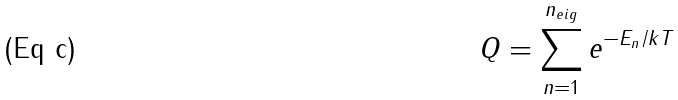<formula> <loc_0><loc_0><loc_500><loc_500>Q = \sum _ { n = 1 } ^ { n _ { e i g } } e ^ { - E _ { n } / k T }</formula> 